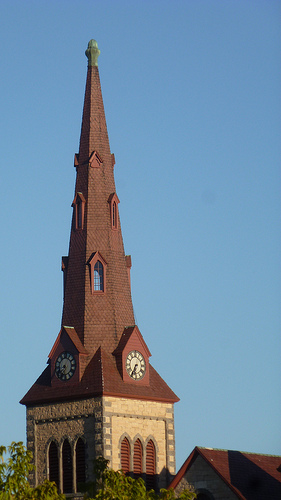Can you tell me about the history of such buildings? Buildings like this one are often historic churches that may date back to the 19th or early 20th century when the gothic revival style was popular for religious architecture, particularly in Europe and North America. What makes these buildings significant? These buildings are significant for their architectural beauty, their role as community landmarks, and often for their historical value, as they might have been central to key events in communal histories. 